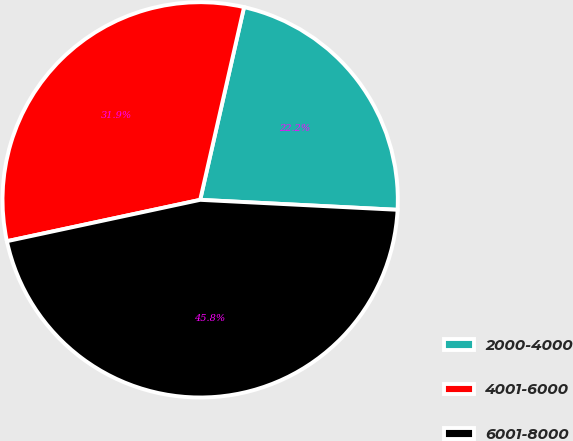<chart> <loc_0><loc_0><loc_500><loc_500><pie_chart><fcel>2000-4000<fcel>4001-6000<fcel>6001-8000<nl><fcel>22.24%<fcel>31.92%<fcel>45.84%<nl></chart> 